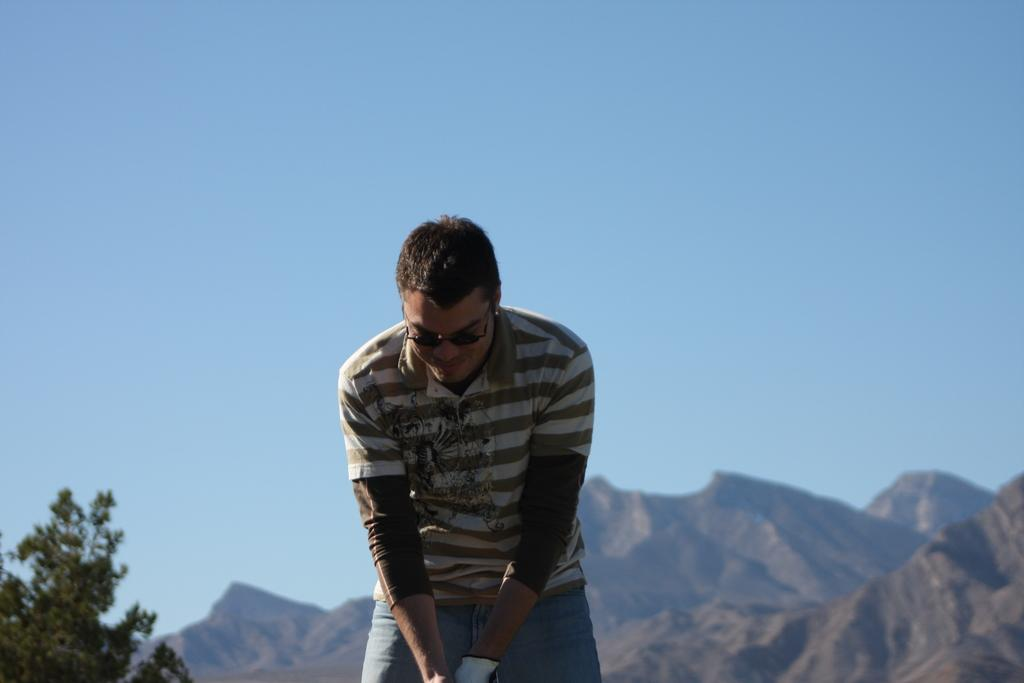What is the man in the image wearing? The man is wearing shades, an at-shirt, and jeans. What can be seen in the background of the image? There are mountains, a tree, and the sky visible in the background of the image. What type of holiday is the man discussing with his friends in the image? There is no indication in the image that the man is discussing a holiday or that he has friends present. 